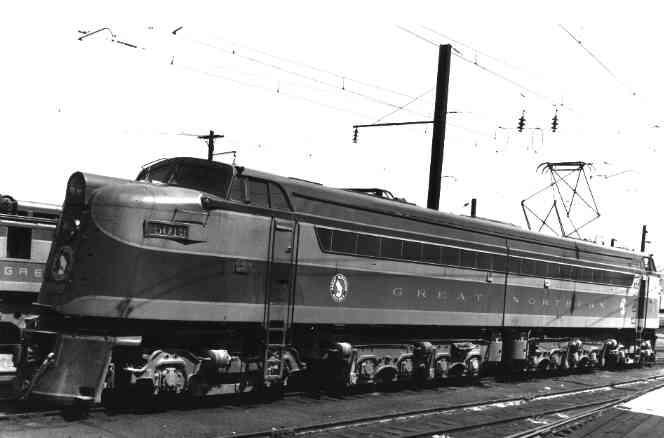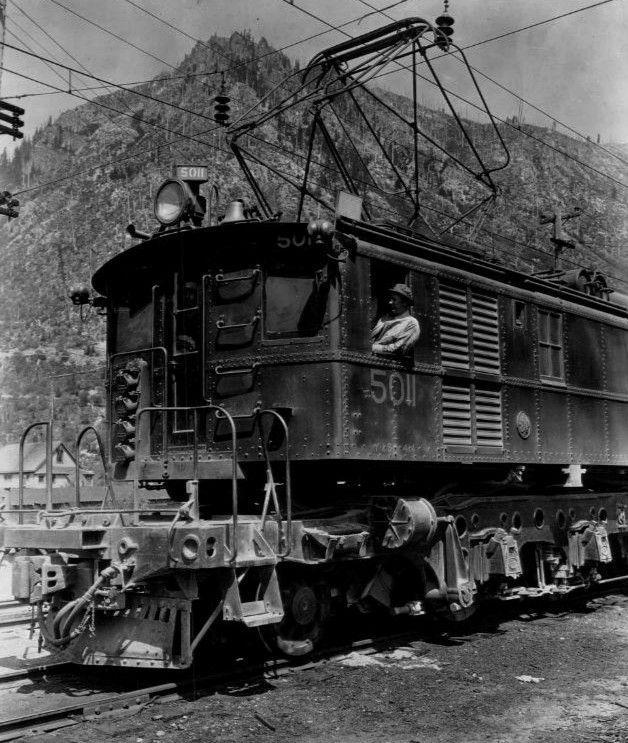The first image is the image on the left, the second image is the image on the right. For the images displayed, is the sentence "One image has a train in front of mountains and is in color." factually correct? Answer yes or no. No. The first image is the image on the left, the second image is the image on the right. Assess this claim about the two images: "There is an electric train travelling on the rails.". Correct or not? Answer yes or no. Yes. 